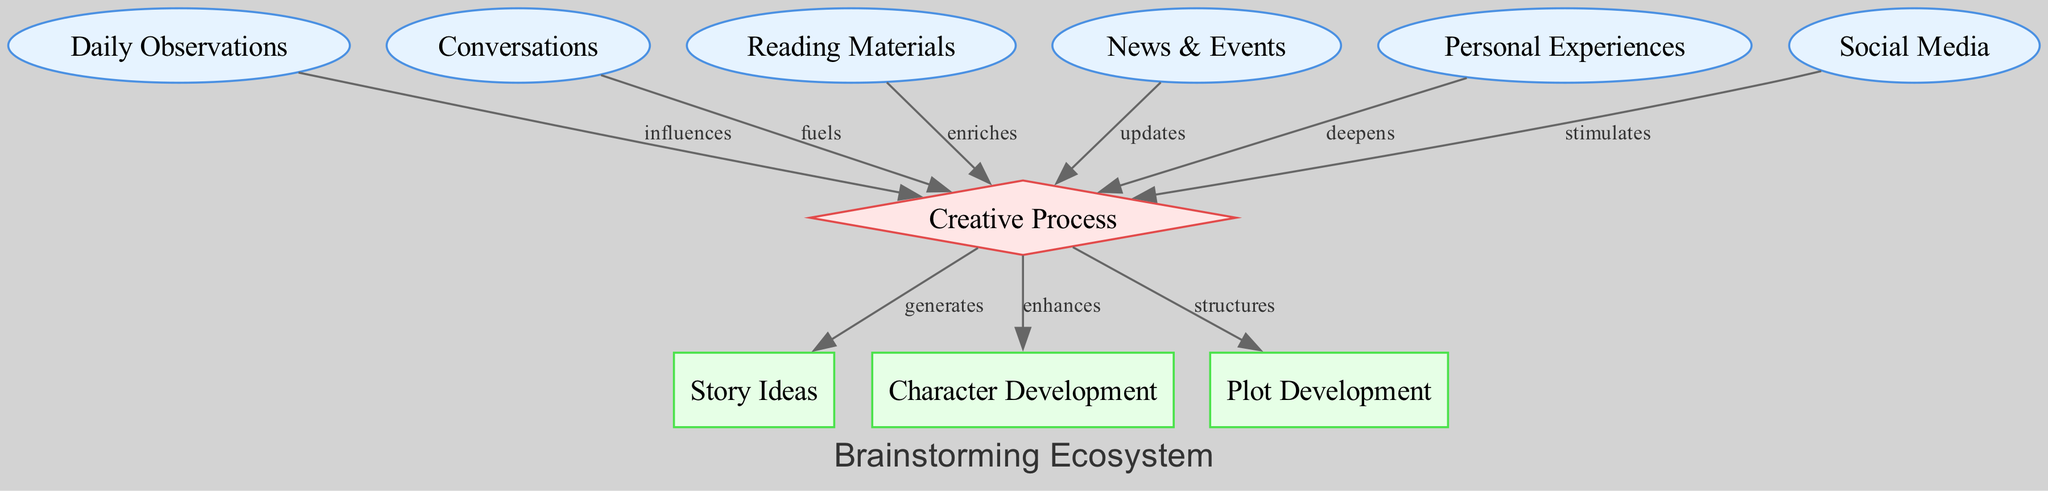What is the total number of nodes in the diagram? There are 10 nodes represented in the diagram, including sources, processes, and outputs.
Answer: 10 Which element influences the Creative Process? The "Daily Observations" influences the "Creative Process" directly, as depicted in the diagram.
Answer: Daily Observations What type of node is "Character Development"? "Character Development" is categorized as an output node in the diagram, indicated by its shape and color.
Answer: output How do "Conversations" affect the Creative Process? "Conversations" fuel the "Creative Process," which means they provide energy or inspire creativity, as shown by the directed edge.
Answer: fuels Which source updates the Creative Process? "News & Events" updates the "Creative Process," providing current information that can influence creativity.
Answer: News & Events What is the relationship between the "Creative Process" and "Story Ideas"? The "Creative Process" generates "Story Ideas," indicating a direct production flow from process to output.
Answer: generates Which elements stimulate the Creative Process? "Daily Observations," "Conversations," "Reading Materials," "News & Events," "Personal Experiences," and "Social Media" all contribute to stimulating the "Creative Process."
Answer: Social Media How many outputs are generated from the Creative Process? There are three outputs derived from the "Creative Process": "Story Ideas," "Character Development," and "Plot Development."
Answer: 3 Which source enriches the Creative Process? "Reading Materials" enriches the "Creative Process," implying that literary resources enhance creativity.
Answer: Reading Materials 